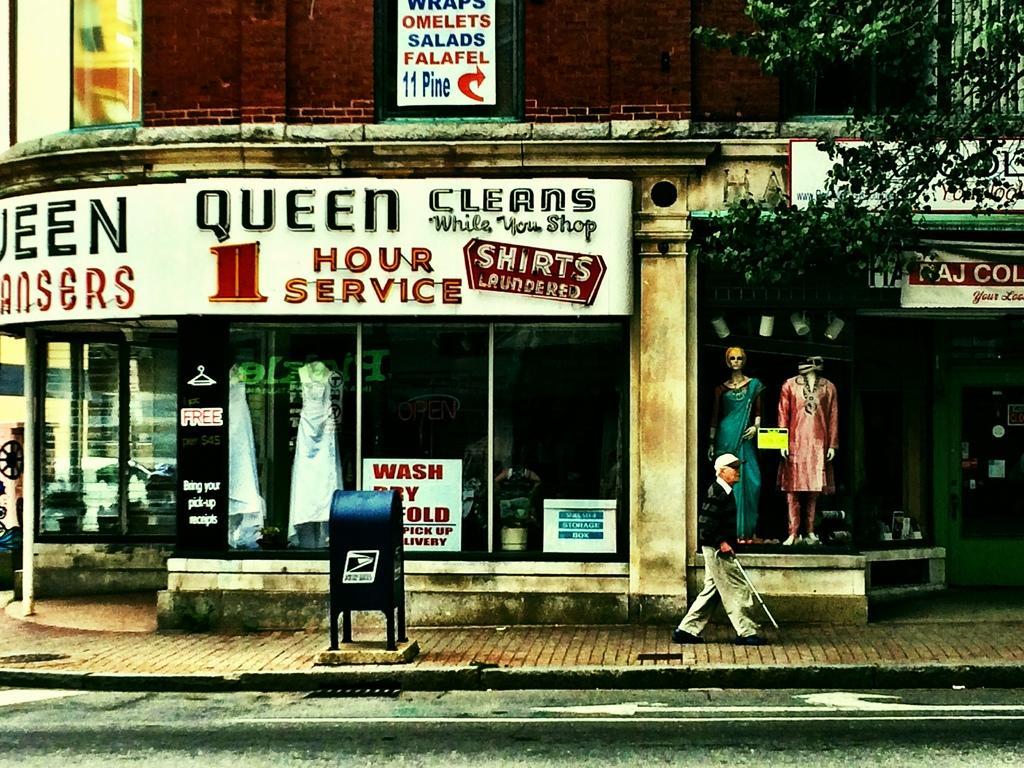In one or two sentences, can you explain what this image depicts? In this image, we can see a stall with glass doors. Here there is a wall, few boards, some box, hoardings, banners. Here we can see few mannequins. At the bottom, we can see the road and platform. A person is walking on the platform and holding a walking stick. Right side of the image, we can see a tree. 